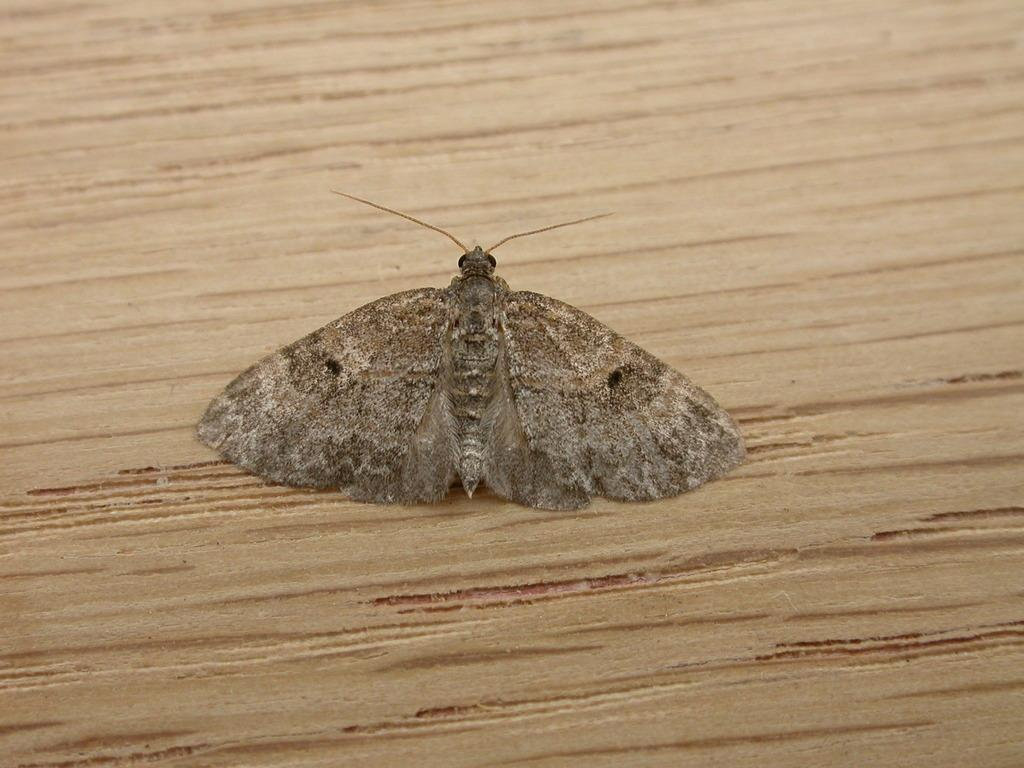What type of insect can be seen in the image? There is a butterfly in the image. Where is the butterfly located? The butterfly is on a table or wood. What type of book is the butterfly holding in the image? There is no book present in the image, and the butterfly is not holding anything. 